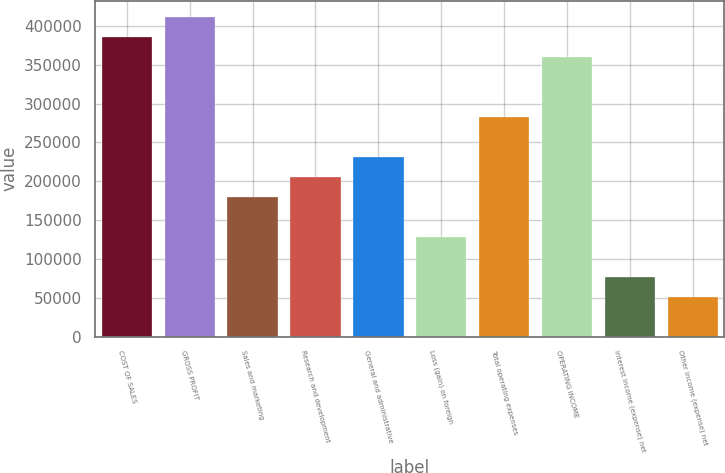<chart> <loc_0><loc_0><loc_500><loc_500><bar_chart><fcel>COST OF SALES<fcel>GROSS PROFIT<fcel>Sales and marketing<fcel>Research and development<fcel>General and administrative<fcel>Loss (gain) on foreign<fcel>Total operating expenses<fcel>OPERATING INCOME<fcel>Interest income (expense) net<fcel>Other income (expense) net<nl><fcel>385881<fcel>411607<fcel>180079<fcel>205804<fcel>231530<fcel>128629<fcel>282980<fcel>360156<fcel>77178.2<fcel>51452.9<nl></chart> 